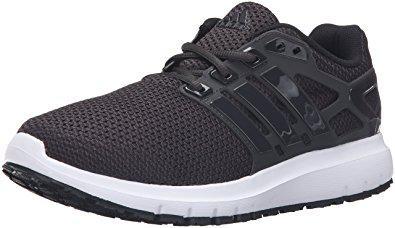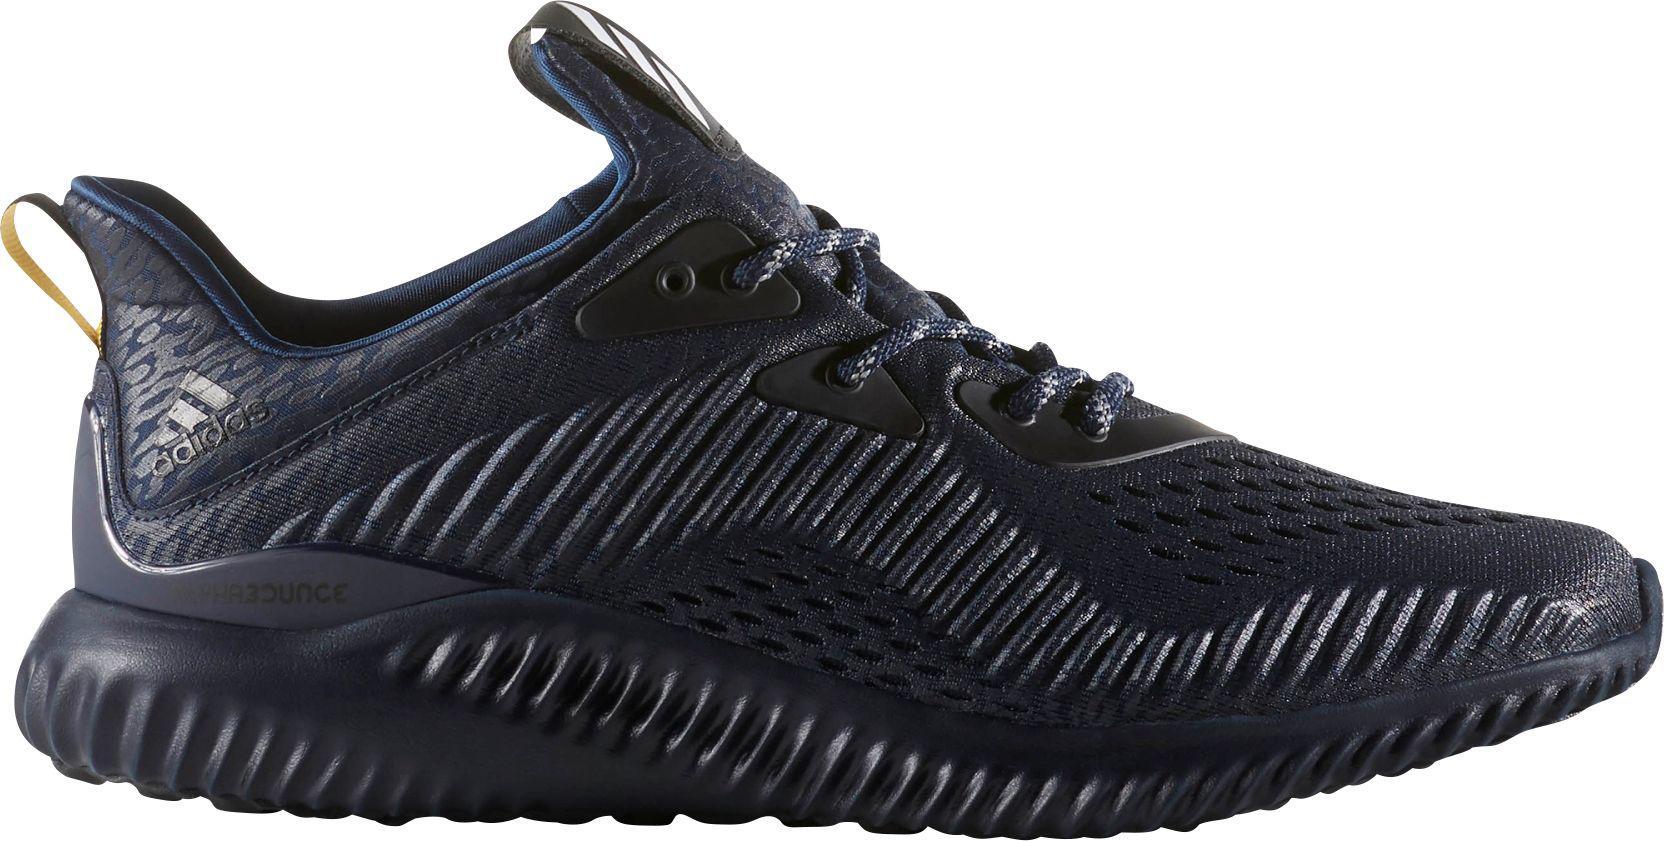The first image is the image on the left, the second image is the image on the right. Evaluate the accuracy of this statement regarding the images: "At least one image has more than one sneaker in it.". Is it true? Answer yes or no. No. 